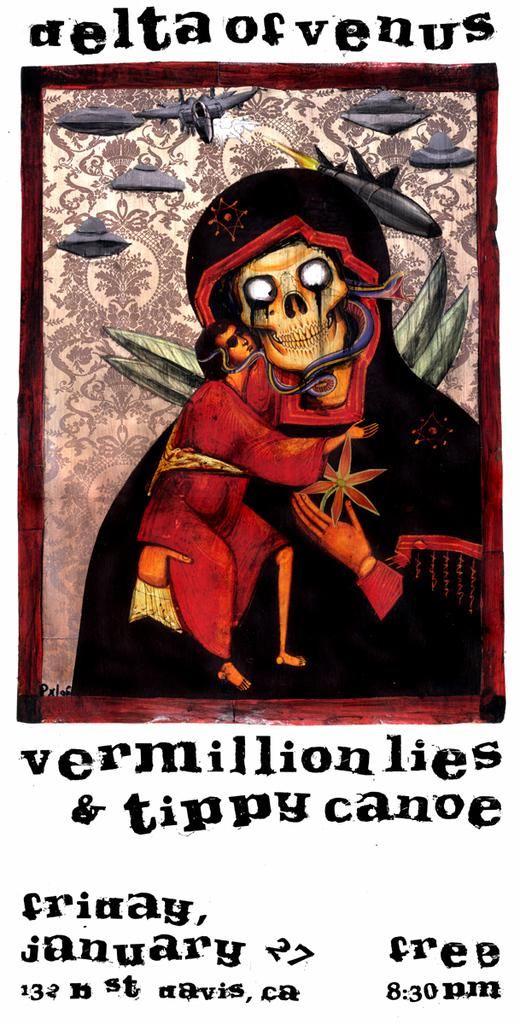<image>
Offer a succinct explanation of the picture presented. Poster titled Delta of Venus showing a person hugging a skeleton. 